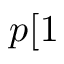Convert formula to latex. <formula><loc_0><loc_0><loc_500><loc_500>p [ 1</formula> 